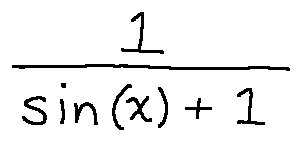<formula> <loc_0><loc_0><loc_500><loc_500>\frac { 1 } { \sin ( x ) + 1 }</formula> 